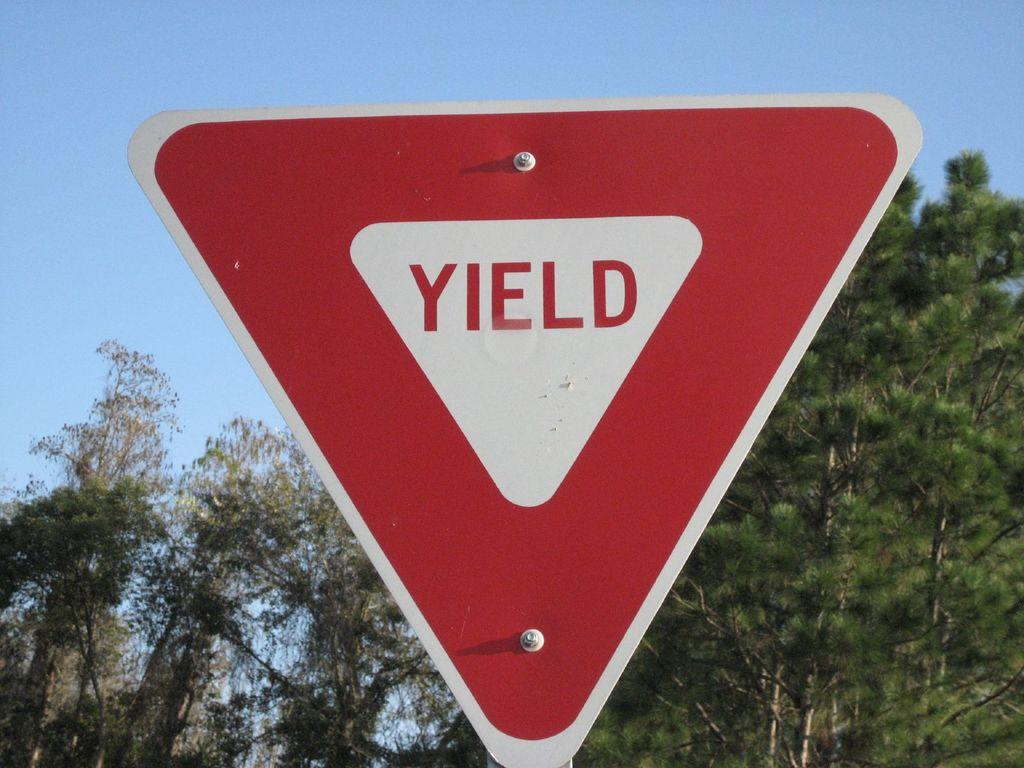<image>
Provide a brief description of the given image. a close up of a YIELD sign with trees in the background 